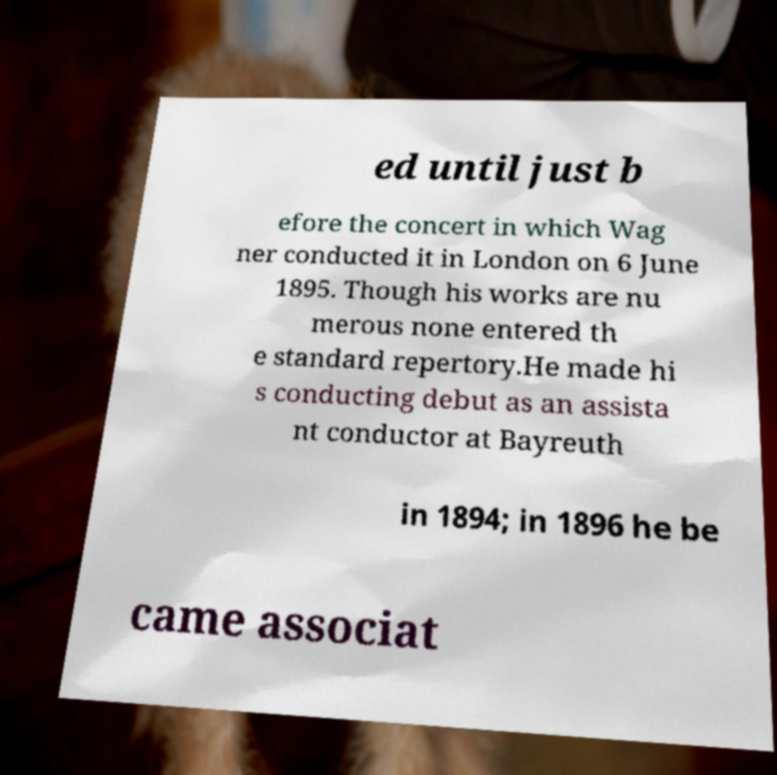Can you accurately transcribe the text from the provided image for me? ed until just b efore the concert in which Wag ner conducted it in London on 6 June 1895. Though his works are nu merous none entered th e standard repertory.He made hi s conducting debut as an assista nt conductor at Bayreuth in 1894; in 1896 he be came associat 